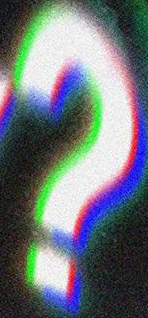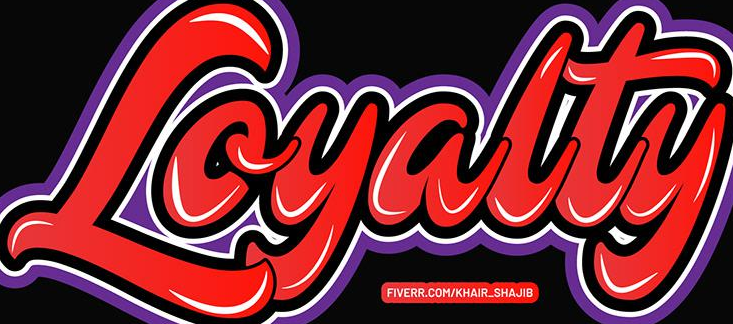Identify the words shown in these images in order, separated by a semicolon. ?; Loyalty 